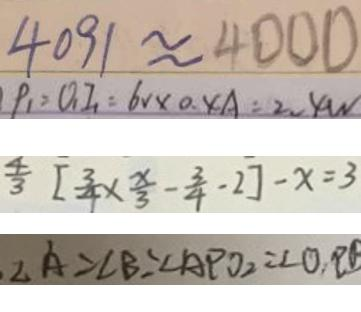Convert formula to latex. <formula><loc_0><loc_0><loc_500><loc_500>4 0 9 1 \approx 4 0 0 0 
 P _ { 1 } = 0 _ { 1 } I _ { 1 } = 6 V \times 0 . 4 A = 2 . 4 W 
 \frac { 4 } { 3 } [ \frac { 3 } { 4 } \times \frac { x } { 3 } - \frac { 3 } { 4 } - 2 ] - x = 3 
 \angle A = \angle B = \angle A P O _ { 2 } = \angle O , P B</formula> 